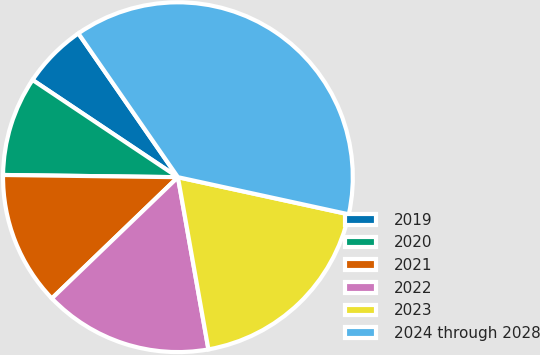<chart> <loc_0><loc_0><loc_500><loc_500><pie_chart><fcel>2019<fcel>2020<fcel>2021<fcel>2022<fcel>2023<fcel>2024 through 2028<nl><fcel>5.98%<fcel>9.18%<fcel>12.39%<fcel>15.6%<fcel>18.8%<fcel>38.04%<nl></chart> 